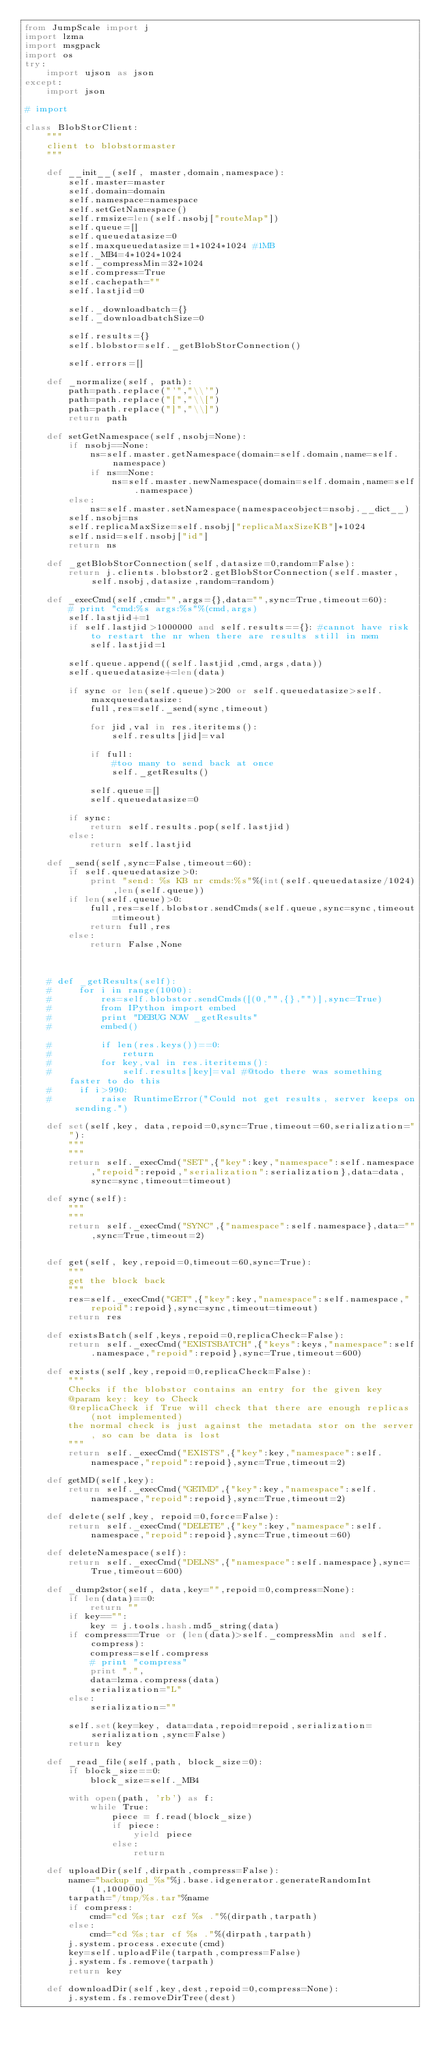<code> <loc_0><loc_0><loc_500><loc_500><_Python_>from JumpScale import j
import lzma
import msgpack
import os
try:
    import ujson as json
except:
    import json
    
# import 

class BlobStorClient:
    """
    client to blobstormaster
    """

    def __init__(self, master,domain,namespace):        
        self.master=master
        self.domain=domain
        self.namespace=namespace
        self.setGetNamespace()
        self.rmsize=len(self.nsobj["routeMap"])
        self.queue=[]
        self.queuedatasize=0
        self.maxqueuedatasize=1*1024*1024 #1MB
        self._MB4=4*1024*1024
        self._compressMin=32*1024
        self.compress=True
        self.cachepath=""
        self.lastjid=0

        self._downloadbatch={}
        self._downloadbatchSize=0

        self.results={}
        self.blobstor=self._getBlobStorConnection()

        self.errors=[]

    def _normalize(self, path):
        path=path.replace("'","\\'")
        path=path.replace("[","\\[")
        path=path.replace("]","\\]")
        return path

    def setGetNamespace(self,nsobj=None):
        if nsobj==None:            
            ns=self.master.getNamespace(domain=self.domain,name=self.namespace)
            if ns==None:            
                ns=self.master.newNamespace(domain=self.domain,name=self.namespace)        
        else:
            ns=self.master.setNamespace(namespaceobject=nsobj.__dict__)
        self.nsobj=ns
        self.replicaMaxSize=self.nsobj["replicaMaxSizeKB"]*1024
        self.nsid=self.nsobj["id"]
        return ns

    def _getBlobStorConnection(self,datasize=0,random=False):
        return j.clients.blobstor2.getBlobStorConnection(self.master,self.nsobj,datasize,random=random)

    def _execCmd(self,cmd="",args={},data="",sync=True,timeout=60):
        # print "cmd:%s args:%s"%(cmd,args)
        self.lastjid+=1
        if self.lastjid>1000000 and self.results=={}: #cannot have risk to restart the nr when there are results still in mem
            self.lastjid=1

        self.queue.append((self.lastjid,cmd,args,data))
        self.queuedatasize+=len(data)
    
        if sync or len(self.queue)>200 or self.queuedatasize>self.maxqueuedatasize:
            full,res=self._send(sync,timeout)
            
            for jid,val in res.iteritems():
                self.results[jid]=val

            if full:
                #too many to send back at once
                self._getResults()

            self.queue=[]
            self.queuedatasize=0
        
        if sync:
            return self.results.pop(self.lastjid)            
        else:
            return self.lastjid

    def _send(self,sync=False,timeout=60):
        if self.queuedatasize>0:
            print "send: %s KB nr cmds:%s"%(int(self.queuedatasize/1024),len(self.queue))
        if len(self.queue)>0:
            full,res=self.blobstor.sendCmds(self.queue,sync=sync,timeout=timeout)
            return full,res
        else:
            return False,None
        


    # def _getResults(self):
    #     for i in range(1000):
    #         res=self.blobstor.sendCmds([(0,"",{},"")],sync=True)
    #         from IPython import embed
    #         print "DEBUG NOW _getResults"
    #         embed()
            
    #         if len(res.keys())==0:
    #             return
    #         for key,val in res.iteritems():
    #             self.results[key]=val #@todo there was something faster to do this
    #     if i>990:
    #         raise RuntimeError("Could not get results, server keeps on sending.")

    def set(self,key, data,repoid=0,sync=True,timeout=60,serialization=""):
        """
        """
        return self._execCmd("SET",{"key":key,"namespace":self.namespace,"repoid":repoid,"serialization":serialization},data=data,sync=sync,timeout=timeout)        

    def sync(self):
        """
        """
        return self._execCmd("SYNC",{"namespace":self.namespace},data="",sync=True,timeout=2)        


    def get(self, key,repoid=0,timeout=60,sync=True):
        """
        get the block back
        """
        res=self._execCmd("GET",{"key":key,"namespace":self.namespace,"repoid":repoid},sync=sync,timeout=timeout) 
        return res

    def existsBatch(self,keys,repoid=0,replicaCheck=False):
        return self._execCmd("EXISTSBATCH",{"keys":keys,"namespace":self.namespace,"repoid":repoid},sync=True,timeout=600) 

    def exists(self,key,repoid=0,replicaCheck=False):
        """
        Checks if the blobstor contains an entry for the given key
        @param key: key to Check
        @replicaCheck if True will check that there are enough replicas (not implemented)
        the normal check is just against the metadata stor on the server, so can be data is lost
        """
        return self._execCmd("EXISTS",{"key":key,"namespace":self.namespace,"repoid":repoid},sync=True,timeout=2)

    def getMD(self,key):
        return self._execCmd("GETMD",{"key":key,"namespace":self.namespace,"repoid":repoid},sync=True,timeout=2) 

    def delete(self,key, repoid=0,force=False):
        return self._execCmd("DELETE",{"key":key,"namespace":self.namespace,"repoid":repoid},sync=True,timeout=60)

    def deleteNamespace(self):
        return self._execCmd("DELNS",{"namespace":self.namespace},sync=True,timeout=600) 

    def _dump2stor(self, data,key="",repoid=0,compress=None):
        if len(data)==0:
            return ""
        if key=="":
            key = j.tools.hash.md5_string(data)
        if compress==True or (len(data)>self._compressMin and self.compress):
            compress=self.compress
            # print "compress"
            print ".",
            data=lzma.compress(data)
            serialization="L"
        else:
            serialization=""

        self.set(key=key, data=data,repoid=repoid,serialization=serialization,sync=False)
        return key

    def _read_file(self,path, block_size=0):
        if block_size==0:
            block_size=self._MB4

        with open(path, 'rb') as f:
            while True:
                piece = f.read(block_size)
                if piece:
                    yield piece
                else:
                    return

    def uploadDir(self,dirpath,compress=False):
        name="backup_md_%s"%j.base.idgenerator.generateRandomInt(1,100000)
        tarpath="/tmp/%s.tar"%name
        if compress:
            cmd="cd %s;tar czf %s ."%(dirpath,tarpath)
        else:
            cmd="cd %s;tar cf %s ."%(dirpath,tarpath)
        j.system.process.execute(cmd)
        key=self.uploadFile(tarpath,compress=False)
        j.system.fs.remove(tarpath)
        return key

    def downloadDir(self,key,dest,repoid=0,compress=None):
        j.system.fs.removeDirTree(dest)</code> 